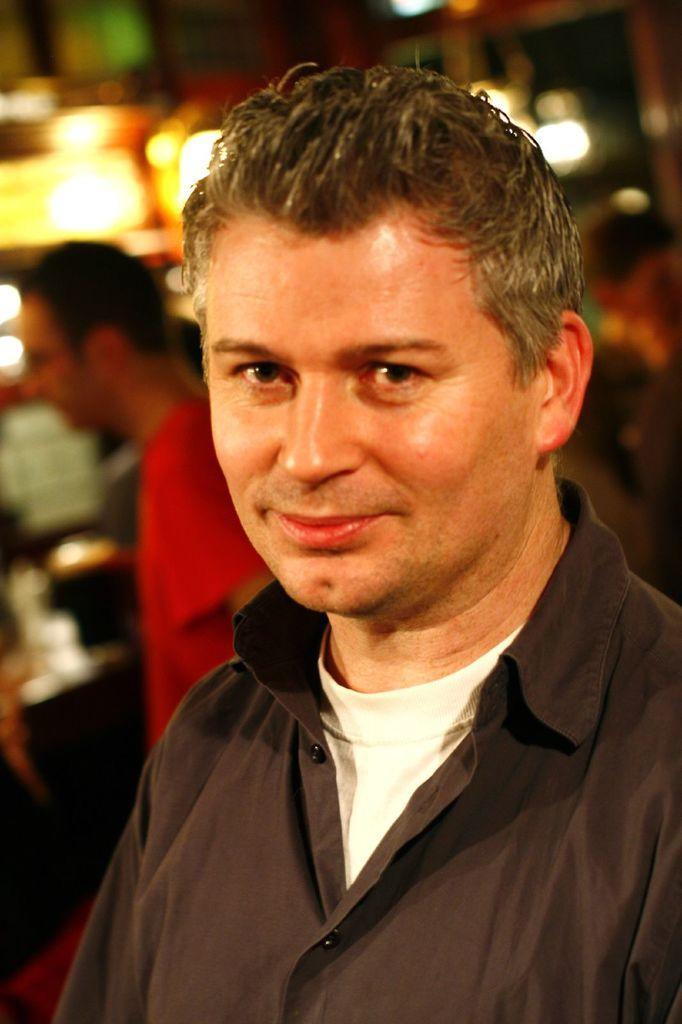What is the main subject in the foreground of the image? There is a man in the foreground of the image. Are there any other people visible in the image? Yes, there are additional persons behind the man. What can be seen in the image besides the people? There are lights visible in the image. How would you describe the background of the image? The background of the image is blurred. What type of arithmetic problem is being solved by the wire in the image? There is no wire present in the image, and therefore no arithmetic problem can be observed. 